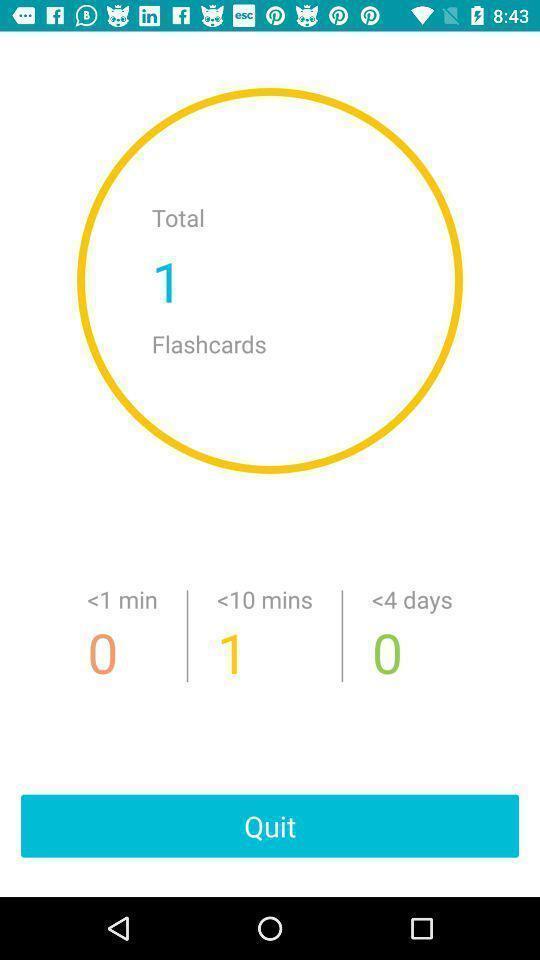Summarize the main components in this picture. Page displaying with flashcards list in learning application. 